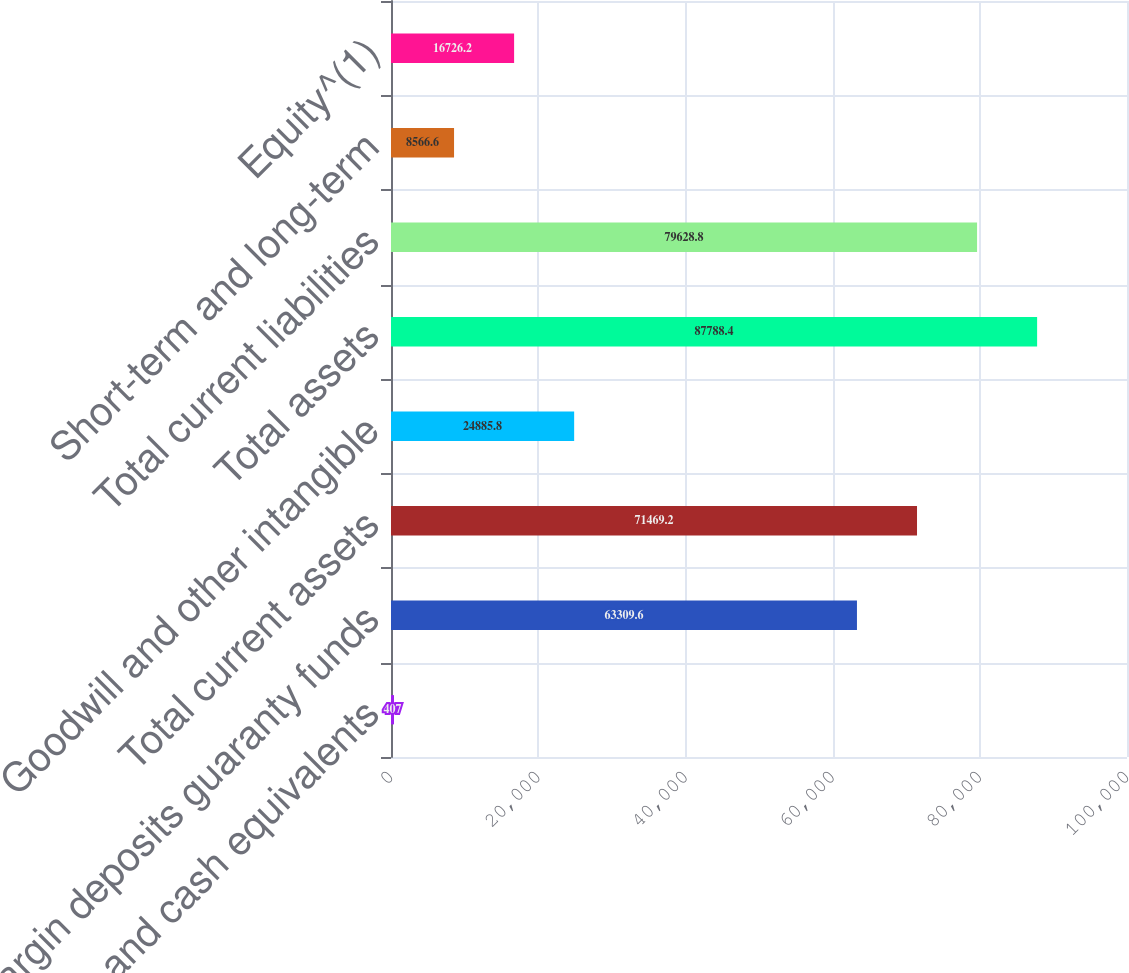<chart> <loc_0><loc_0><loc_500><loc_500><bar_chart><fcel>Cash and cash equivalents<fcel>Margin deposits guaranty funds<fcel>Total current assets<fcel>Goodwill and other intangible<fcel>Total assets<fcel>Total current liabilities<fcel>Short-term and long-term<fcel>Equity^(1)<nl><fcel>407<fcel>63309.6<fcel>71469.2<fcel>24885.8<fcel>87788.4<fcel>79628.8<fcel>8566.6<fcel>16726.2<nl></chart> 